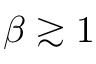Convert formula to latex. <formula><loc_0><loc_0><loc_500><loc_500>\beta \gtrsim 1</formula> 